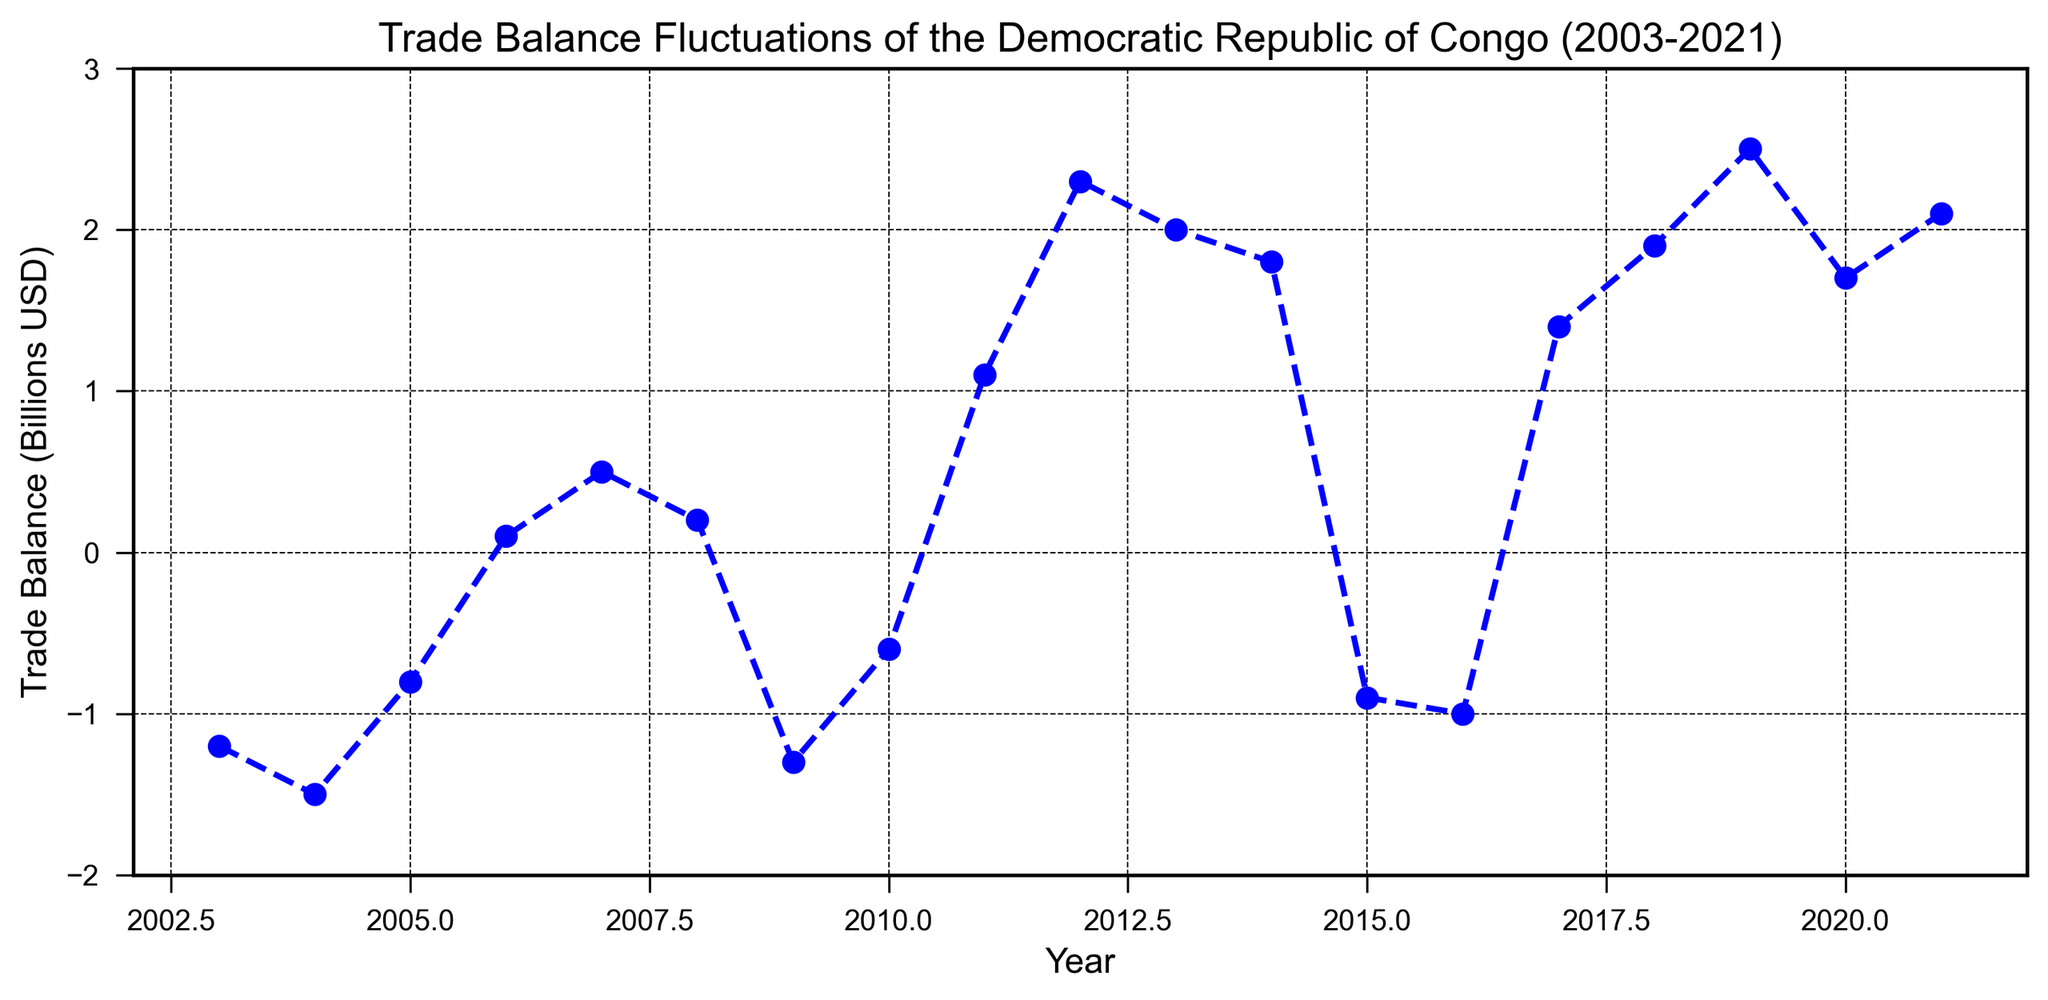What was the trade balance in 2011? Referring to the provided figure, locate the year 2011 on the x-axis and trace it to the trade balance value on the y-axis.
Answer: 1.1 How many years had a negative trade balance? Identify the years where the trade balance lies below the zero line on the y-axis. These years are 2003, 2004, 2005, 2009, 2010, 2015, and 2016, which total 7 years.
Answer: 7 Which year experienced the most significant trade balance deficit? The most significant deficit corresponds to the lowest point on the chart. Locate the lowest point, which is in 2004, with a trade balance of -1.5 billion USD.
Answer: 2004 Compare the trade balance of 2008 and 2018. Which year had a higher trade balance? Locate 2008 and 2018 on the x-axis and compare their trade balance values. 2008 shows 0.2 billion USD, and 2018 shows 1.9 billion USD.
Answer: 2018 What is the trend in trade balance from 2019 to 2021? Identify the points for 2019, 2020, and 2021. Trace the line segment connecting these points to observe the overall trend. The trade balance decreases from 2.5 billion USD in 2019 to 1.7 billion USD in 2020, then increases to 2.1 billion USD in 2021.
Answer: Decrease then Increase What's the average trade balance from 2010 to 2020? Sum the trade balances from 2010 to 2020 (1.1 + 2.3 + 2.0 + 1.8 - 0.9 - 1.0 + 1.4 + 1.9 + 2.5 + 1.7) which equals 14.8, then divide by the number of years (11): 14.8 / 11 ≈ 1.345 billion USD.
Answer: 1.345 During which period (2003-2010 or 2011-2021) did the Democratic Republic of Congo achieve a higher average trade balance? Calculate the average trade balance for 2003-2010 and 2011-2021 periods. 
For 2003-2010: (-1.2 - 1.5 - 0.8 + 0.1 + 0.5 + 0.2 - 1.3 - 0.6) / 8 ≈ -0.575.
For 2011-2021: (1.1 + 2.3 + 2.0 + 1.8 - 0.9 - 1.0 + 1.4 + 1.9 + 2.5 + 1.7 + 2.1) / 11 ≈ 1.345.
Comparing the two averages, 2011-2021 period has a higher average.
Answer: 2011-2021 Identify a year when the trade balance was neutral. Locate a point where the trade balance equals zero on the y-axis. The year 2006 has a trade balance of 0.1, which is closest to neutral.
Answer: 2006 What is the difference in trade balance between the best and worst years? Identify the best year (2019: 2.5 billion USD) and the worst year (2004: -1.5 billion USD). Calculate the difference: 2.5 - (-1.5) = 4.0 billion USD.
Answer: 4.0 